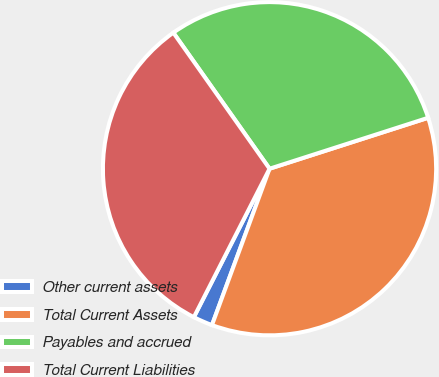<chart> <loc_0><loc_0><loc_500><loc_500><pie_chart><fcel>Other current assets<fcel>Total Current Assets<fcel>Payables and accrued<fcel>Total Current Liabilities<nl><fcel>1.89%<fcel>35.56%<fcel>29.85%<fcel>32.7%<nl></chart> 